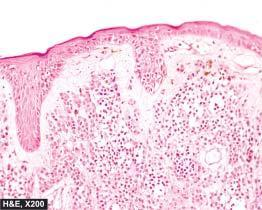re the individual cells in layers coarse and irregular?
Answer the question using a single word or phrase. No 